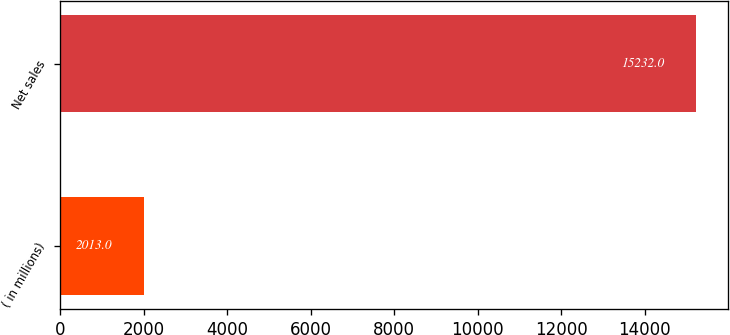<chart> <loc_0><loc_0><loc_500><loc_500><bar_chart><fcel>( in millions)<fcel>Net sales<nl><fcel>2013<fcel>15232<nl></chart> 